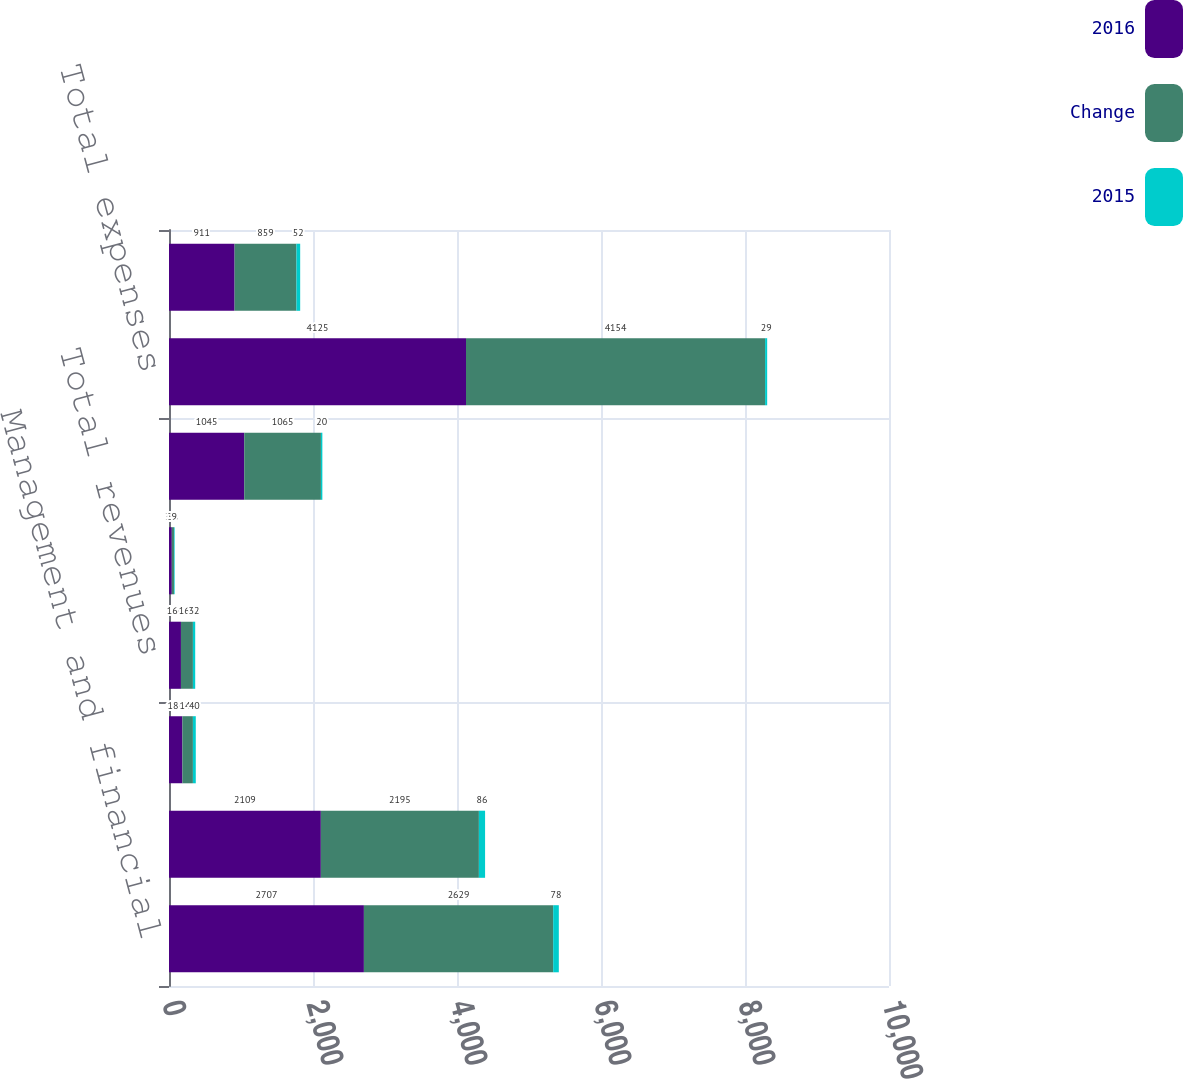<chart> <loc_0><loc_0><loc_500><loc_500><stacked_bar_chart><ecel><fcel>Management and financial<fcel>Distribution fees<fcel>Net investment income<fcel>Total revenues<fcel>Banking and deposit interest<fcel>General and administrative<fcel>Total expenses<fcel>Operating earnings<nl><fcel>2016<fcel>2707<fcel>2109<fcel>186<fcel>166<fcel>39<fcel>1045<fcel>4125<fcel>911<nl><fcel>Change<fcel>2629<fcel>2195<fcel>146<fcel>166<fcel>30<fcel>1065<fcel>4154<fcel>859<nl><fcel>2015<fcel>78<fcel>86<fcel>40<fcel>32<fcel>9<fcel>20<fcel>29<fcel>52<nl></chart> 